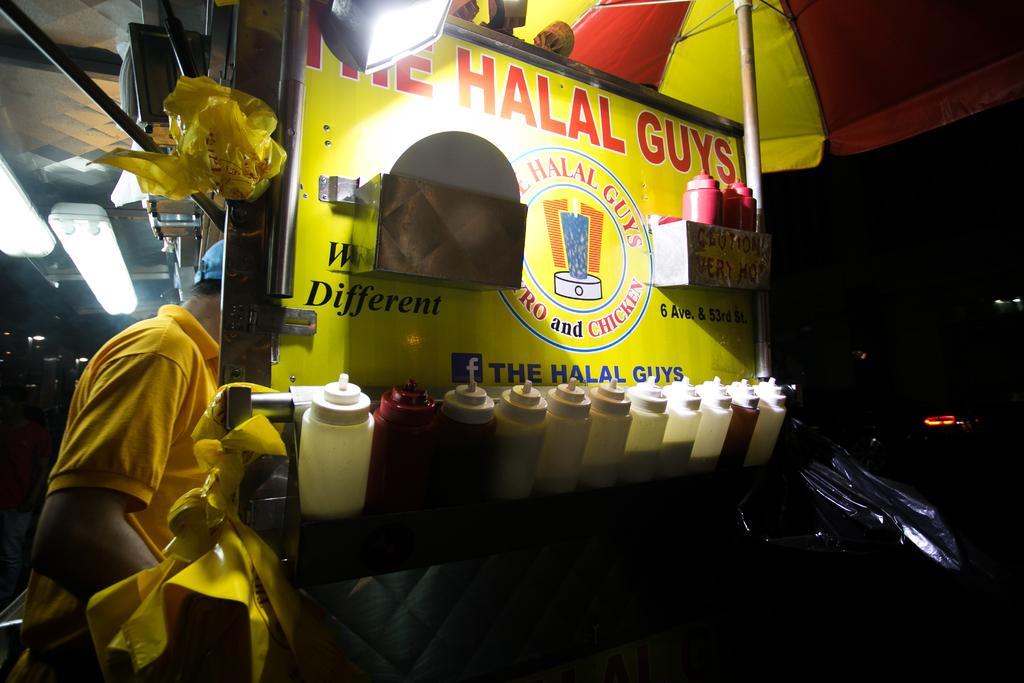How would you summarize this image in a sentence or two? In this picture we can see there are bottles on an object. Behind the bottles there is a board. On the left side of the bottles there is a person in the yellow t shirt. On the right side of the bottles it is dark. 